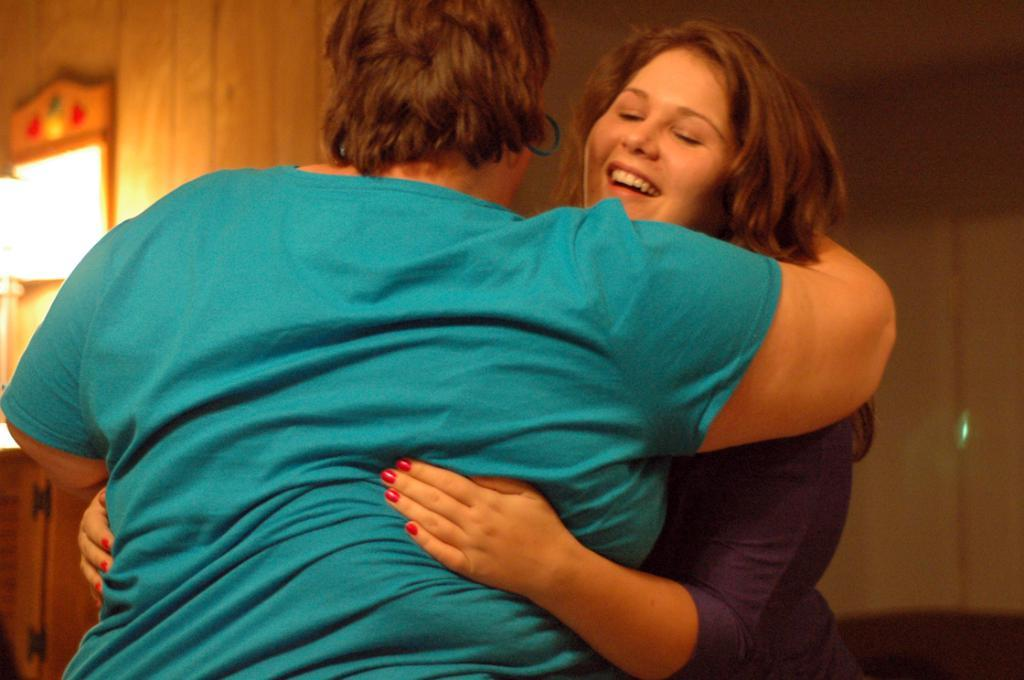How many people are in the image? There are two persons in the image. What are the two persons doing in the image? The two persons are hugging each other. Can you describe the facial expression of one of the persons? One of the persons is smiling. What can be seen in the background of the image? There is a wall in the background of the image. What type of acoustics can be heard in the image? There is no information about any sounds or acoustics in the image, so it cannot be determined. Is the mother of one of the persons present in the image? There is no information about the relationship between the persons or the presence of a mother in the image. How many chickens are visible in the image? There are no chickens present in the image. 